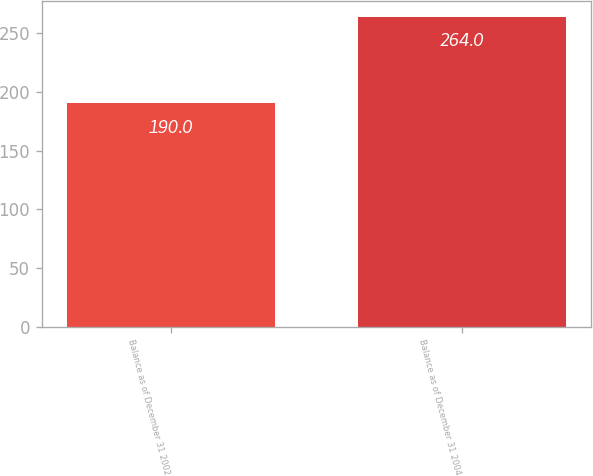Convert chart to OTSL. <chart><loc_0><loc_0><loc_500><loc_500><bar_chart><fcel>Balance as of December 31 2002<fcel>Balance as of December 31 2004<nl><fcel>190<fcel>264<nl></chart> 